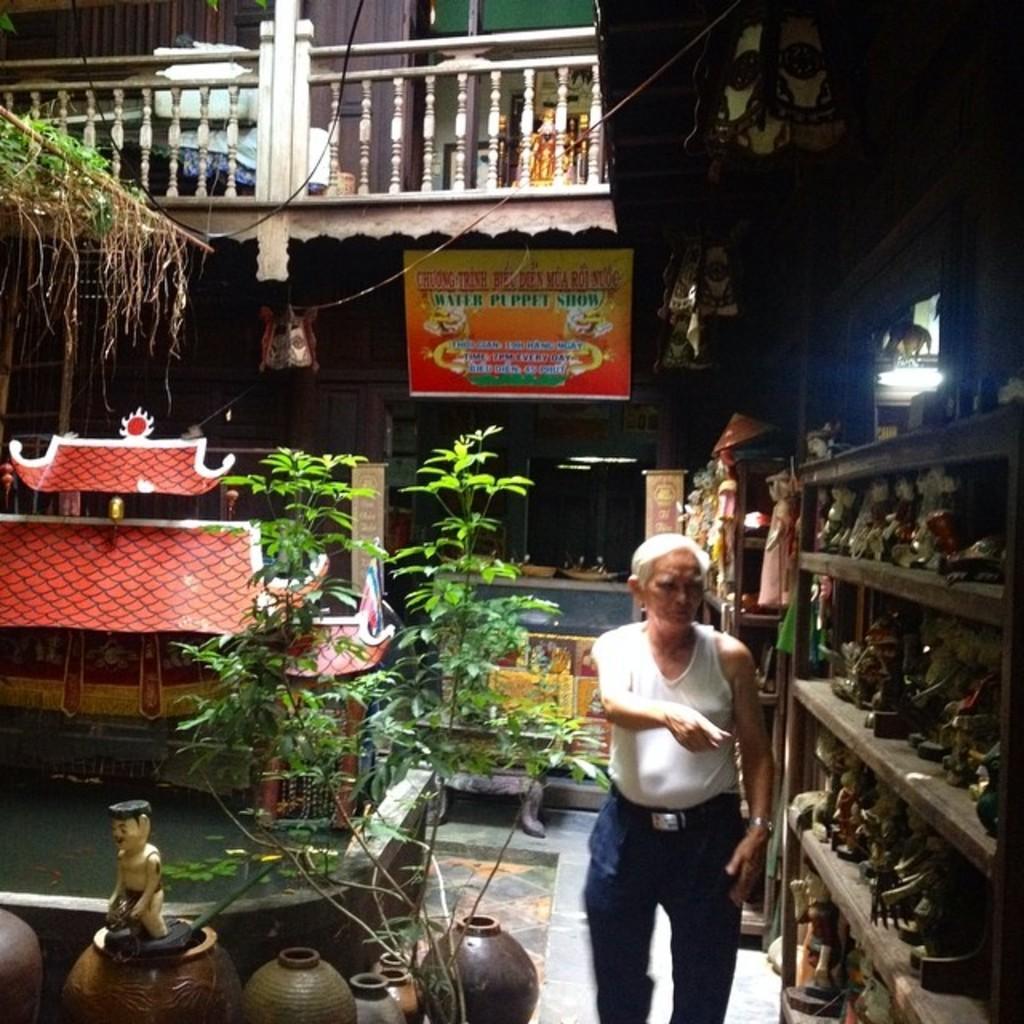Describe this image in one or two sentences. In this image we can see an old person standing and pointing towards the objects beside there are plants and decor objects, behind there is a board and a wooden railing. 